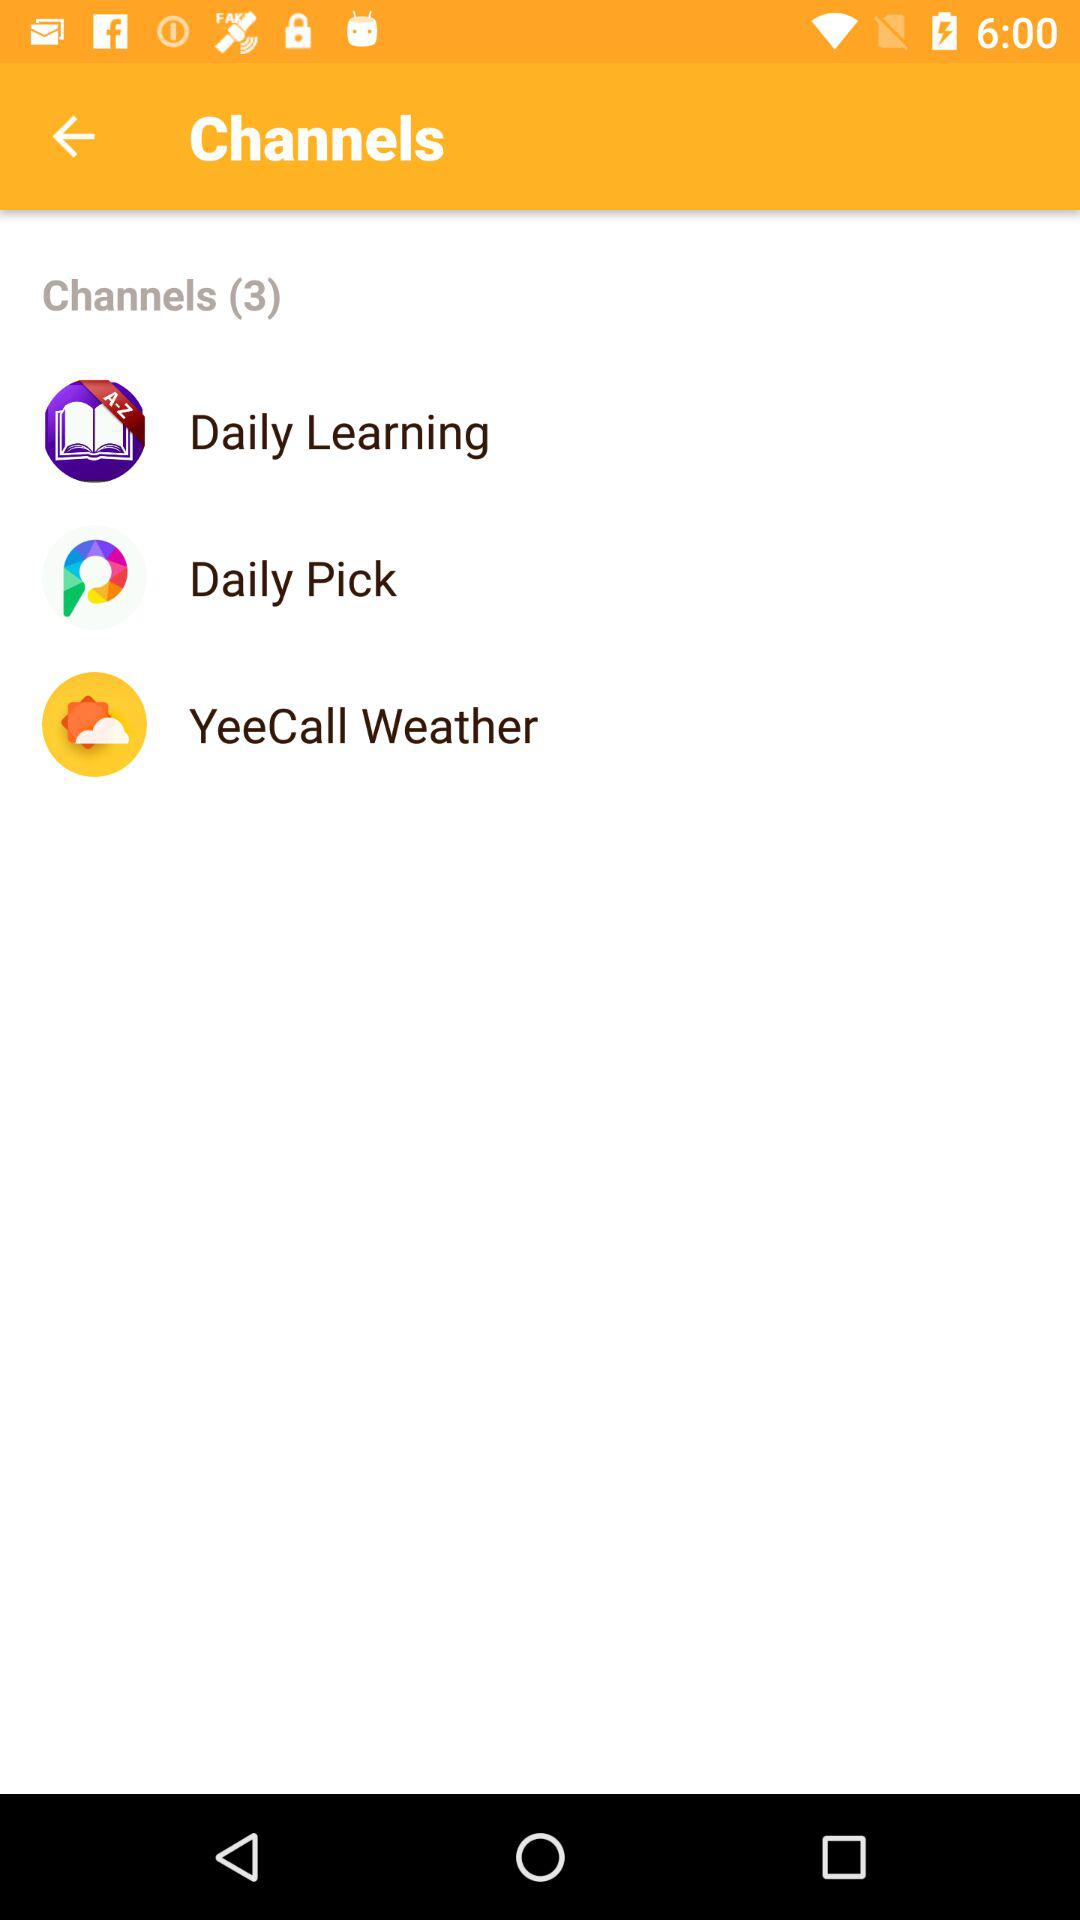What are the different types of channels? The different types of channels are "Daily Learning", "Daily Pick" and "YeeCall Weather". 